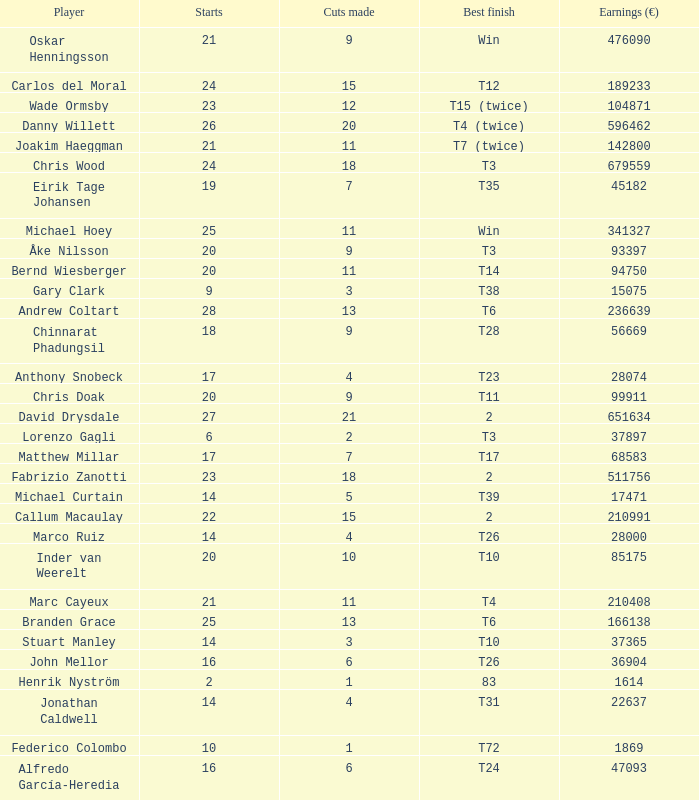How many cuts did Gary Clark make? 3.0. 